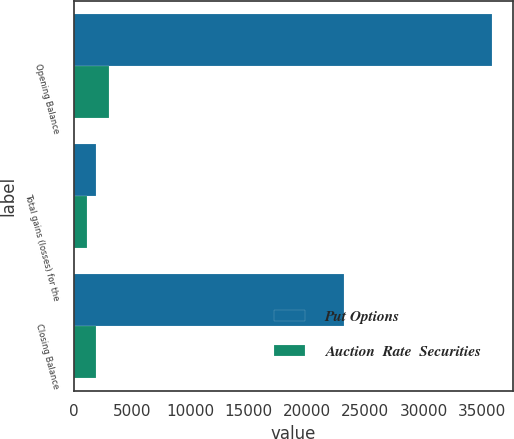Convert chart to OTSL. <chart><loc_0><loc_0><loc_500><loc_500><stacked_bar_chart><ecel><fcel>Opening Balance<fcel>Total gains (losses) for the<fcel>Closing Balance<nl><fcel>Put Options<fcel>35852<fcel>1897<fcel>23156<nl><fcel>Auction  Rate  Securities<fcel>3041<fcel>1112<fcel>1929<nl></chart> 